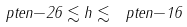<formula> <loc_0><loc_0><loc_500><loc_500>\ p t e n { - 2 6 } \lesssim h \lesssim \ p t e n { - 1 6 }</formula> 